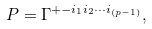<formula> <loc_0><loc_0><loc_500><loc_500>P = \Gamma ^ { + - i _ { 1 } i _ { 2 } \cdots i _ { ( p - 1 ) } } ,</formula> 